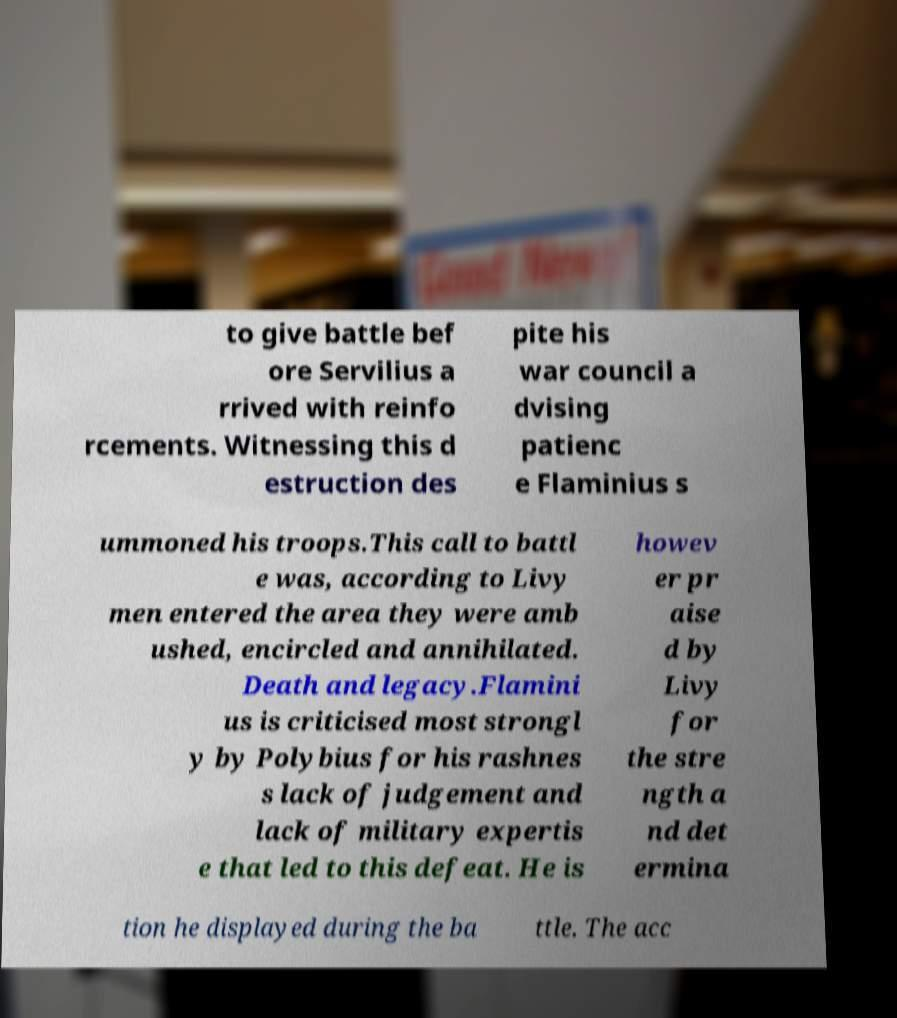Can you accurately transcribe the text from the provided image for me? to give battle bef ore Servilius a rrived with reinfo rcements. Witnessing this d estruction des pite his war council a dvising patienc e Flaminius s ummoned his troops.This call to battl e was, according to Livy men entered the area they were amb ushed, encircled and annihilated. Death and legacy.Flamini us is criticised most strongl y by Polybius for his rashnes s lack of judgement and lack of military expertis e that led to this defeat. He is howev er pr aise d by Livy for the stre ngth a nd det ermina tion he displayed during the ba ttle. The acc 